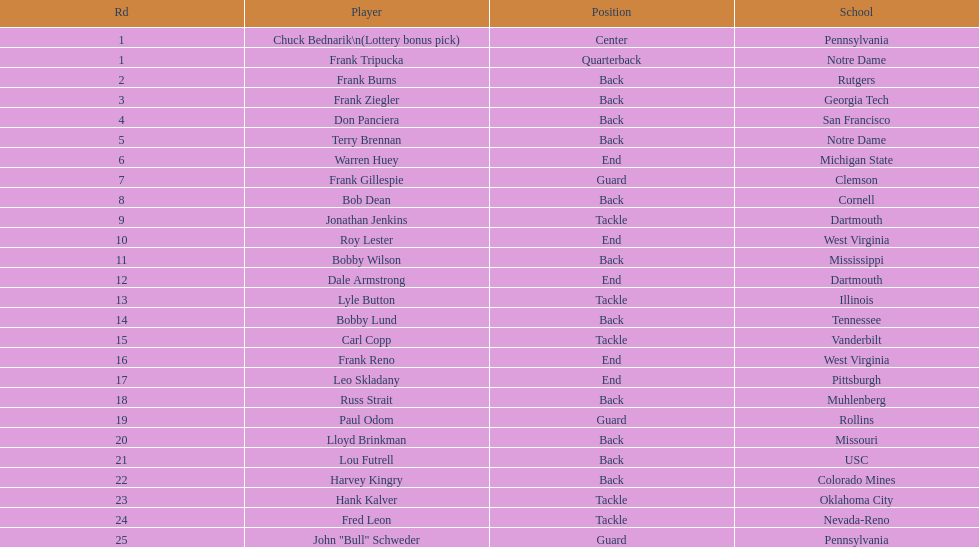Highest rd number? 25. 